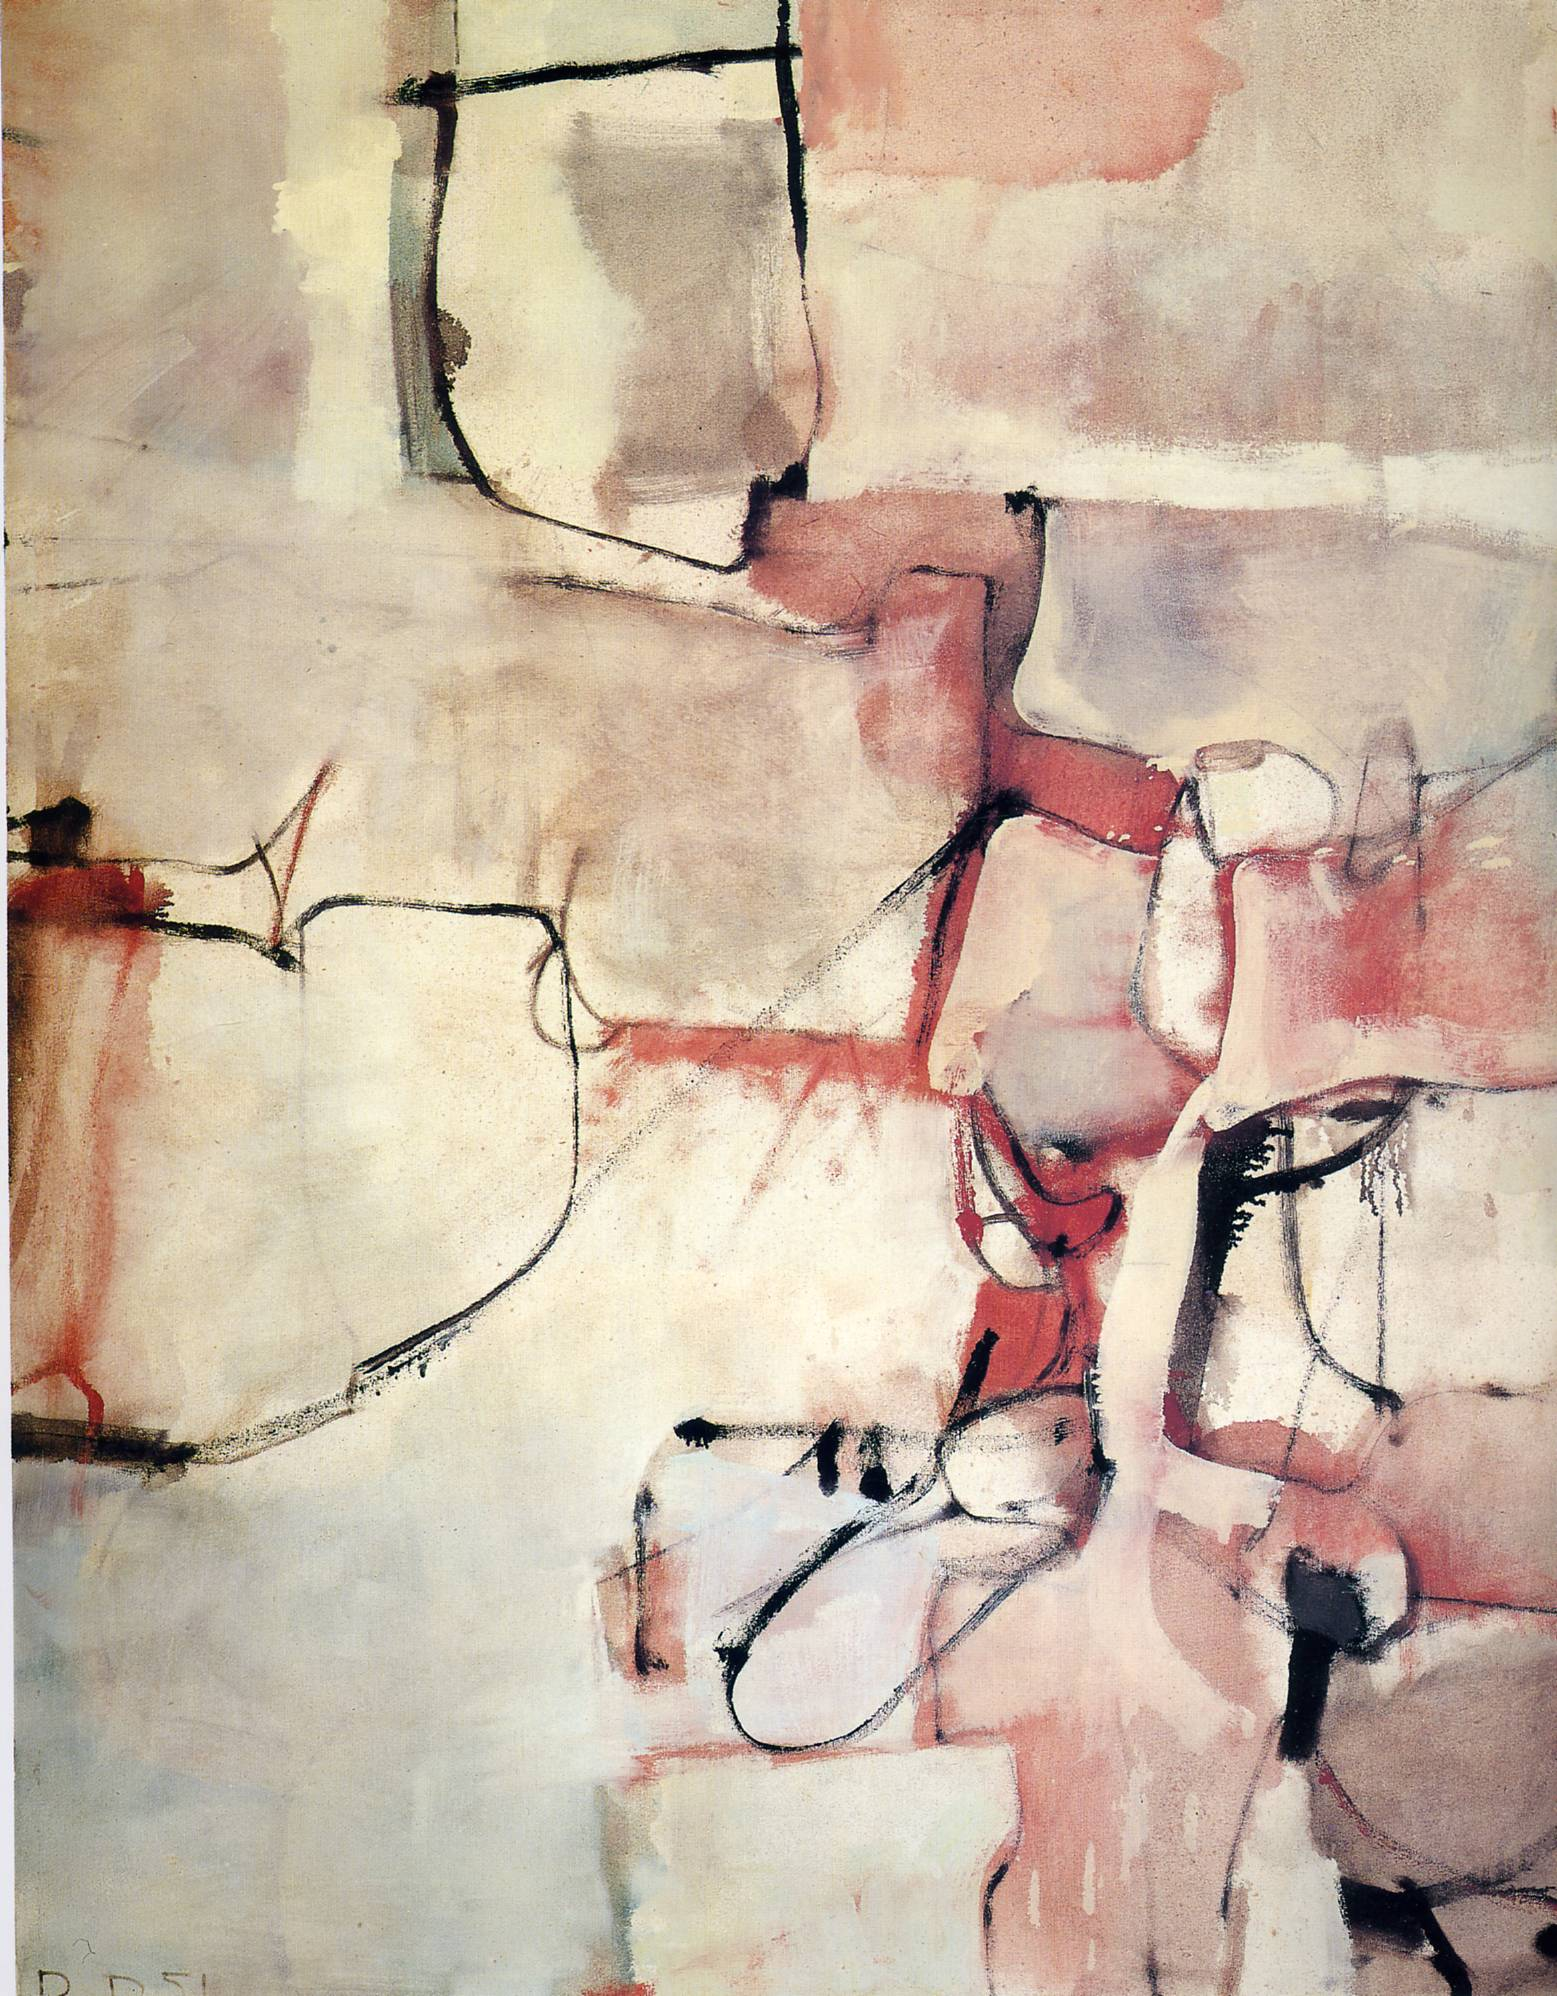Write a detailed description of the given image. The image is an evocative abstract painting dominated by a blend of red, pink, and beige tones that create a harmonious yet emotionally intense atmosphere. This artwork reflects the cubist influence, noted for depicting subjects from various perspectives and deconstructing them into geometric shapes, which is visible in the fragmented forms and intersecting lines. The style also hints at abstract expressionism through its expressive use of colors and forms designed to evoke emotions and engage the viewer at a deeper emotional level. The composition cleverly balances fullness and emptiness, employing blank canvas spaces to enhance visual interest and contrast, making the vibrant colors and bold shapes stand out more distinctly. Additionally, the soft, blurred edges of the forms, along with the stark black lines, add a dynamic tension and a sense of movement to the static image, inviting viewers to explore the painting's depth and meaning. 